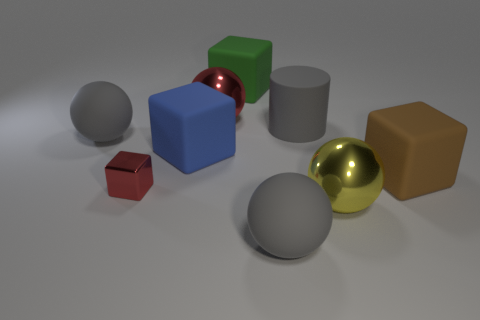Subtract all matte cubes. How many cubes are left? 1 Subtract all red spheres. How many spheres are left? 3 Subtract 3 spheres. How many spheres are left? 1 Add 8 yellow metallic balls. How many yellow metallic balls exist? 9 Subtract 1 red spheres. How many objects are left? 8 Subtract all cylinders. How many objects are left? 8 Subtract all gray cubes. Subtract all cyan cylinders. How many cubes are left? 4 Subtract all blue cubes. How many blue balls are left? 0 Subtract all tiny metal cubes. Subtract all small blue matte blocks. How many objects are left? 8 Add 6 brown cubes. How many brown cubes are left? 7 